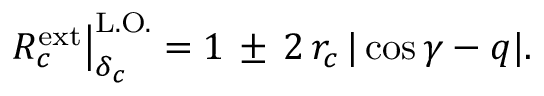<formula> <loc_0><loc_0><loc_500><loc_500>R _ { c } ^ { e x t } \right | _ { \delta _ { c } } ^ { L . O . } = 1 \, \pm \, 2 \, r _ { c } \, | \cos \gamma - q | .</formula> 